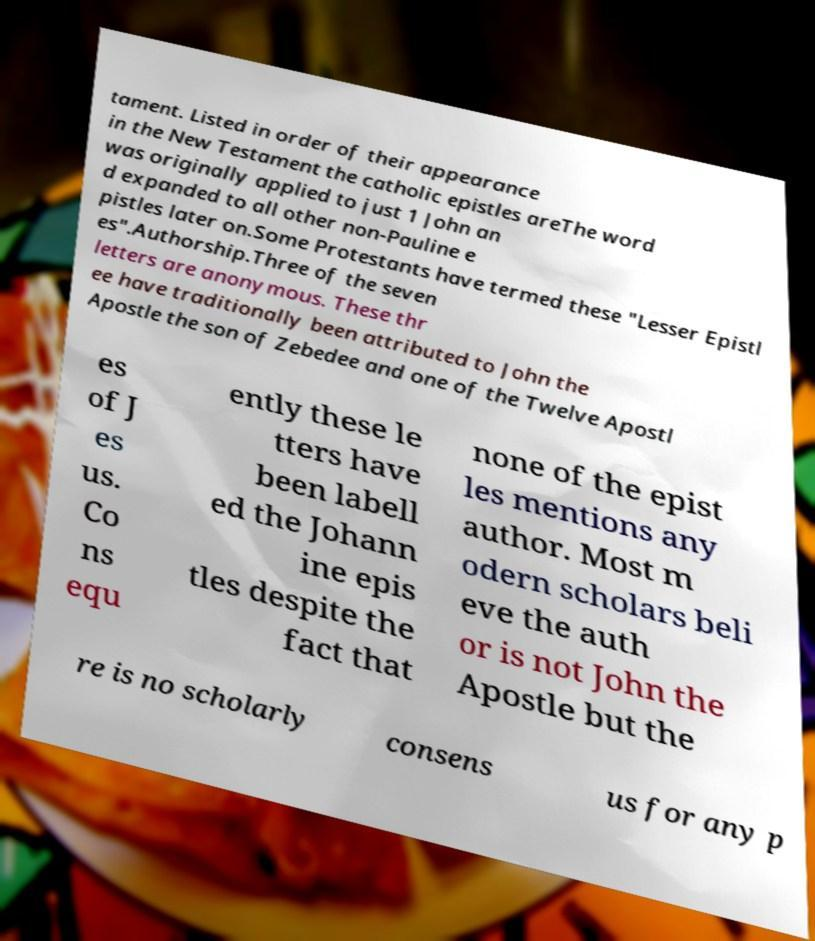Please identify and transcribe the text found in this image. tament. Listed in order of their appearance in the New Testament the catholic epistles areThe word was originally applied to just 1 John an d expanded to all other non-Pauline e pistles later on.Some Protestants have termed these "Lesser Epistl es".Authorship.Three of the seven letters are anonymous. These thr ee have traditionally been attributed to John the Apostle the son of Zebedee and one of the Twelve Apostl es of J es us. Co ns equ ently these le tters have been labell ed the Johann ine epis tles despite the fact that none of the epist les mentions any author. Most m odern scholars beli eve the auth or is not John the Apostle but the re is no scholarly consens us for any p 